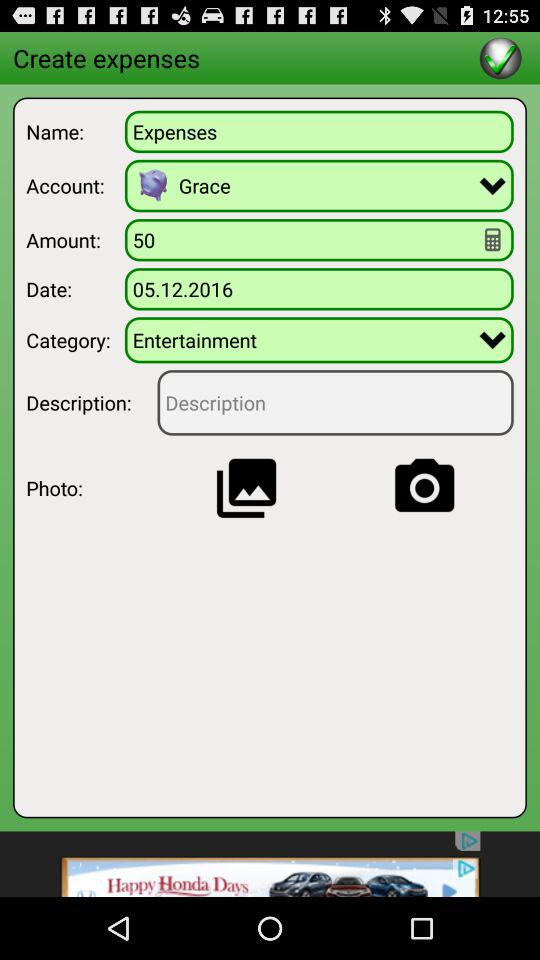Which category is selected? The selected category is "Entertainment". 